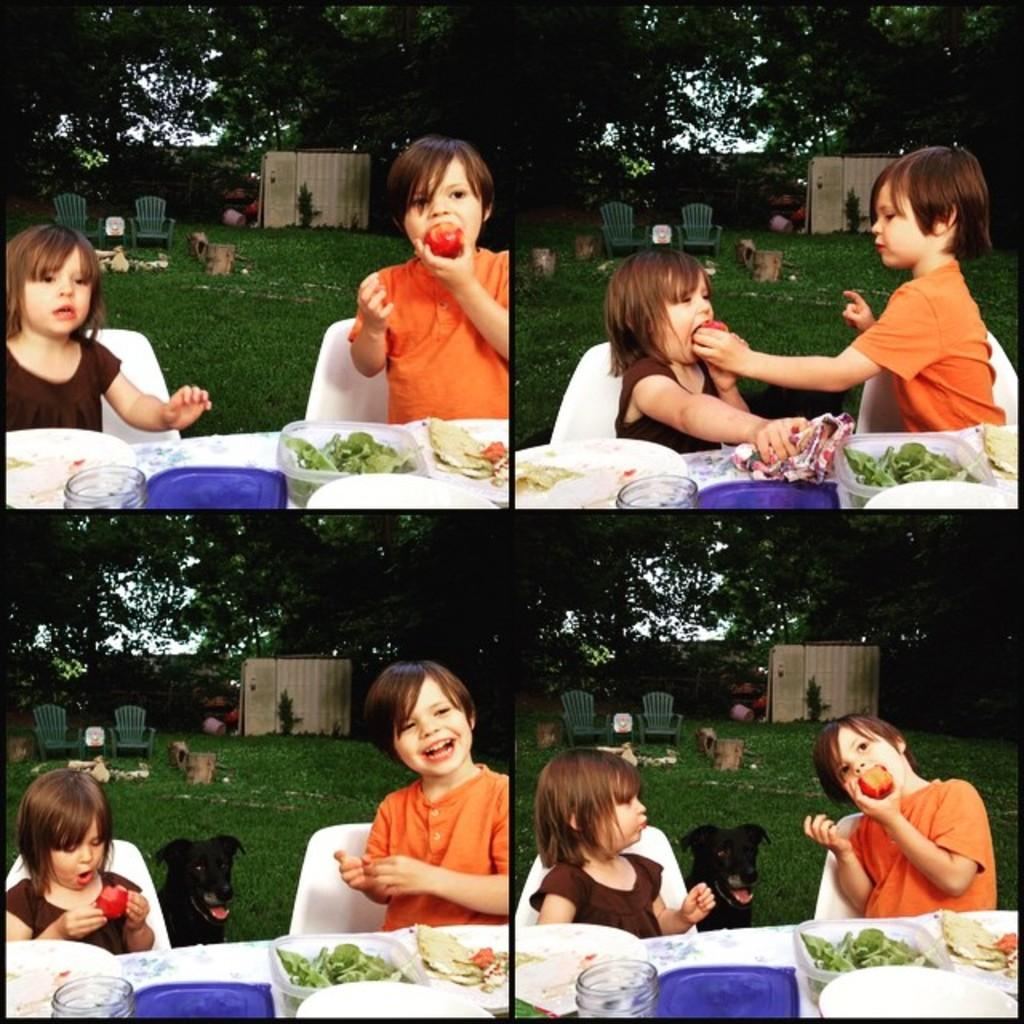Can you describe this image briefly? The image is inside the garden. The image is divided into four parts the first part, there are two kids and the orange color boy is eating an apple. On right side the girl is a eating an apple and sitting on chair in front on table, on table we can see boxes,jar and some food. On left side we can also see a dog in image in background there are some trees and chair. 